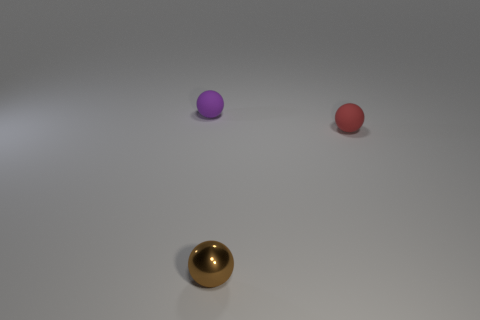There is a thing that is in front of the tiny red sphere; does it have the same shape as the purple rubber thing?
Ensure brevity in your answer.  Yes. Is there anything else that has the same material as the brown object?
Your answer should be compact. No. How many objects are either shiny objects or matte balls that are on the left side of the brown sphere?
Provide a short and direct response. 2. Are there more small objects behind the tiny red thing than brown spheres that are to the left of the tiny purple object?
Ensure brevity in your answer.  Yes. There is a small purple thing; is its shape the same as the object in front of the tiny red rubber thing?
Your answer should be very brief. Yes. How many other things are there of the same shape as the brown metallic thing?
Provide a short and direct response. 2. The sphere that is on the right side of the purple sphere and left of the tiny red rubber object is what color?
Give a very brief answer. Brown. The small shiny object has what color?
Your response must be concise. Brown. Does the purple ball have the same material as the small thing in front of the red ball?
Make the answer very short. No. There is a thing that is made of the same material as the small purple ball; what shape is it?
Make the answer very short. Sphere. 